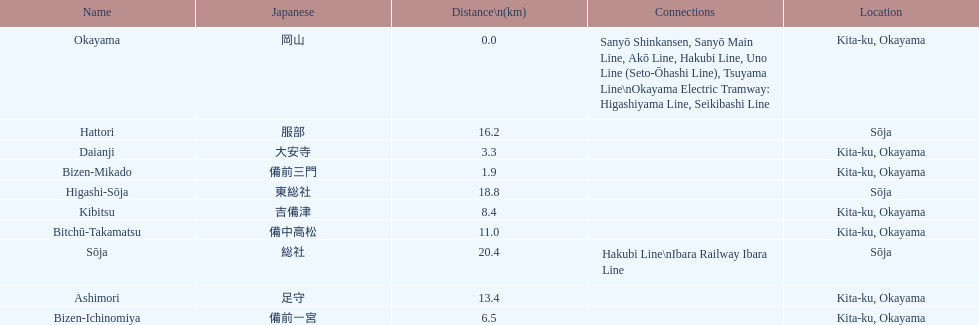Which has the most distance, hattori or kibitsu? Hattori. 